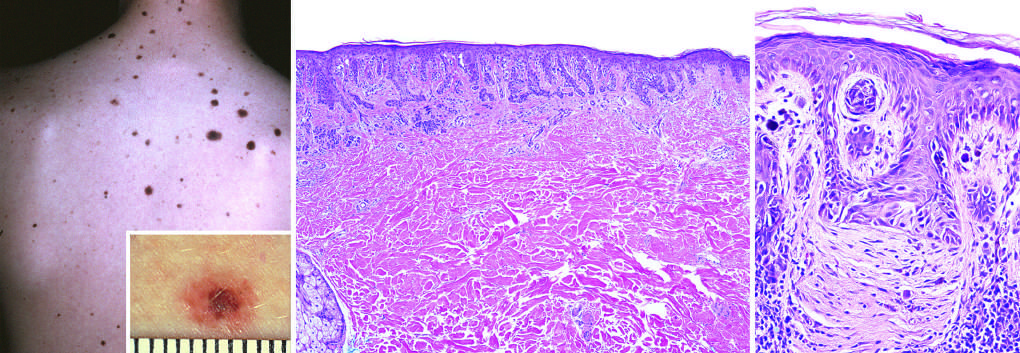what corresponds to the raised, more pigmented central zone seen in the figure inset?
Answer the question using a single word or phrase. The central dermal component 